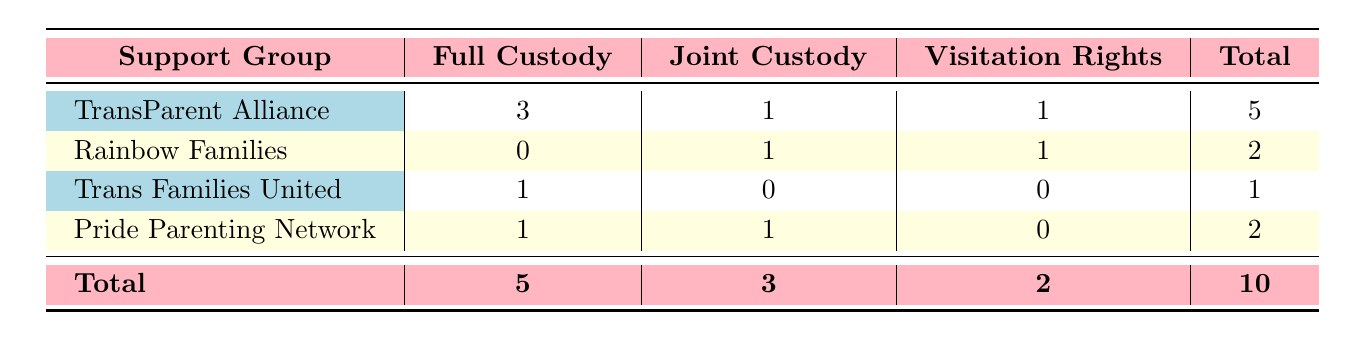What is the total number of parents who participated in the TransParent Alliance? From the table, under the "TransParent Alliance" row, the total number of legal outcomes listed is 5. This means there are 5 parents who participated in this support group.
Answer: 5 How many parents retained full custody across all support groups? By looking at the "Full Custody" column, we see the TransParent Alliance has 3, Pride Parenting Network has 1, and Trans Families United has 1. Adding these values gives us 3 + 1 + 1 = 5.
Answer: 5 Is it true that Rainbow Families had no parents retaining full custody? In the "Rainbow Families" row, the "Full Custody" column shows 0, indicating that no parents from this support group retained full custody.
Answer: Yes What is the total number of parents awarded joint custody? Summing the numbers in the "Joint Custody" column gives us 1 from Rainbow Families, 1 from Pride Parenting Network, and 0 from Trans Families United, which totals 1 + 1 + 0 = 2.
Answer: 2 Which support group had the highest number of parents awarded visitation rights? The "Visitation Rights" column shows TransParent Alliance has 1, Rainbow Families has 1, and Pride Parenting Network has 0. They are all tied with the same value, so the answer is that the highest is 1, shared by both TransParent Alliance and Rainbow Families.
Answer: TransParent Alliance and Rainbow Families How many support groups had parents retaining custody (full or joint)? Looking through the "Full Custody" and "Joint Custody" columns, TransParent Alliance had 3 full, Rainbow Families had 1 joint, and Pride Parenting Network had 1 full. Counting these groups gives us 3 + 1 + 1 = 5 groups.
Answer: 4 What percentage of parents in the Pride Parenting Network were awarded full custody? There is 1 parent from the Pride Parenting Network who retained full custody out of 2 total (1 full and 1 joint). The percentage is calculated as (1/2) * 100 = 50%.
Answer: 50% Are there more parents with visitation rights or parents with full custody? In total, there are 2 visitation rights (1 from TransParent Alliance and 1 from Rainbow Families) and 5 full custody. Since 5 > 2, it is clear that there are more parents with full custody.
Answer: More parents retained full custody 